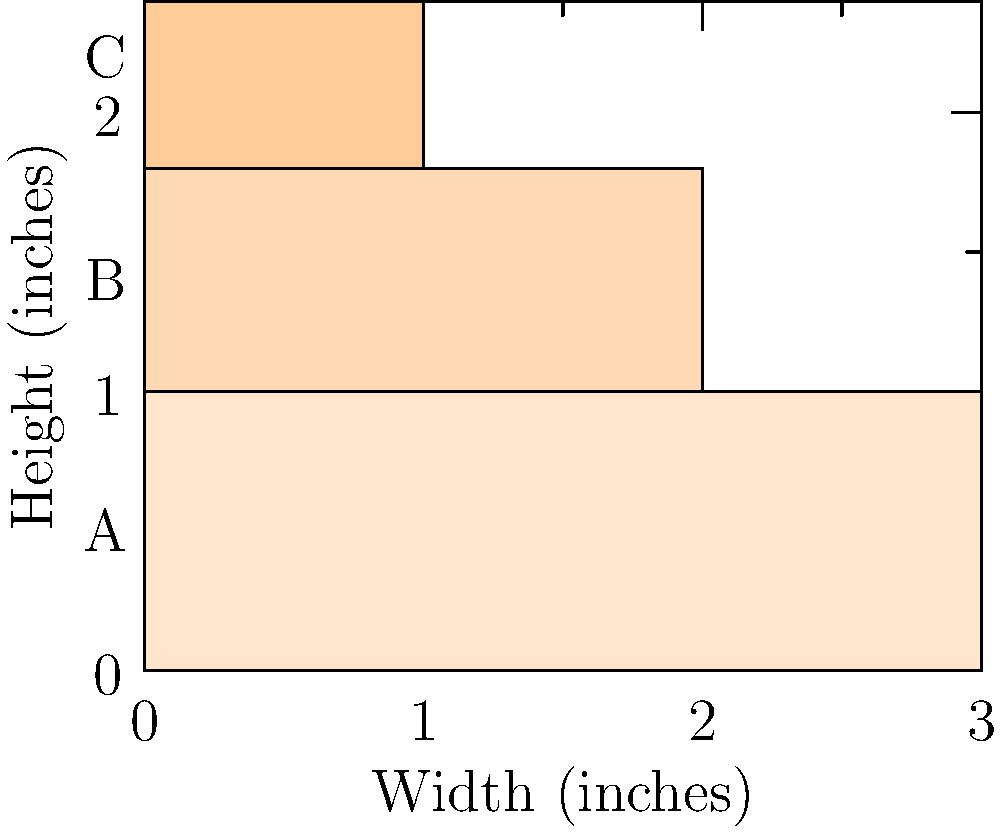As a pastry chef specializing in wedding cakes, you're designing a three-tiered cake. The diagram shows the layers labeled A, B, and C from bottom to top. If the total height of the cake is 9.6 inches, and each tier's height is proportional to its width, what is the height of the middle tier (B) in inches? Let's approach this step-by-step:

1. Observe that the widths of the tiers decrease from bottom to top.
2. Let's denote the heights of tiers A, B, and C as $h_A$, $h_B$, and $h_C$ respectively.
3. Given that the total height is 9.6 inches: $h_A + h_B + h_C = 9.6$
4. From the diagram, we can see that the widths of the tiers are in the ratio 3:2:1.
5. Since the height of each tier is proportional to its width, we can say:
   $h_A : h_B : h_C = 3 : 2 : 1$
6. Let's express $h_A$ and $h_C$ in terms of $h_B$:
   $h_A = \frac{3}{2}h_B$ and $h_C = \frac{1}{2}h_B$
7. Substituting these into the total height equation:
   $\frac{3}{2}h_B + h_B + \frac{1}{2}h_B = 9.6$
8. Simplifying: $3h_B = 9.6$
9. Solving for $h_B$: $h_B = 9.6 \div 3 = 3.2$

Therefore, the height of the middle tier (B) is 3.2 inches.
Answer: 3.2 inches 